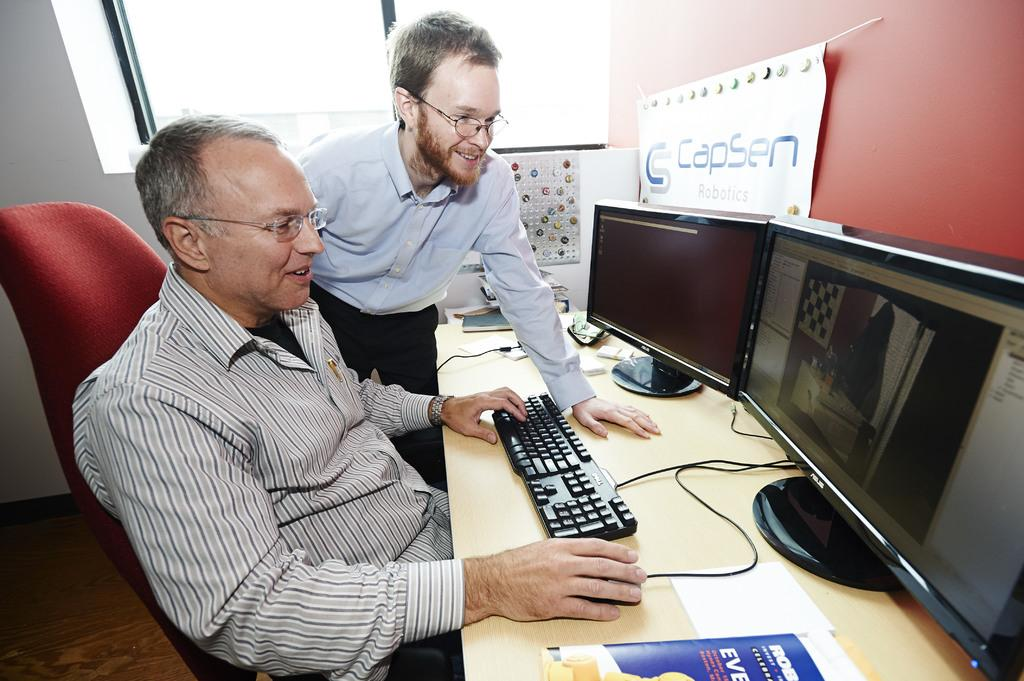Provide a one-sentence caption for the provided image. Two men are working on a computer with a sign that says Capsen Robotics. 